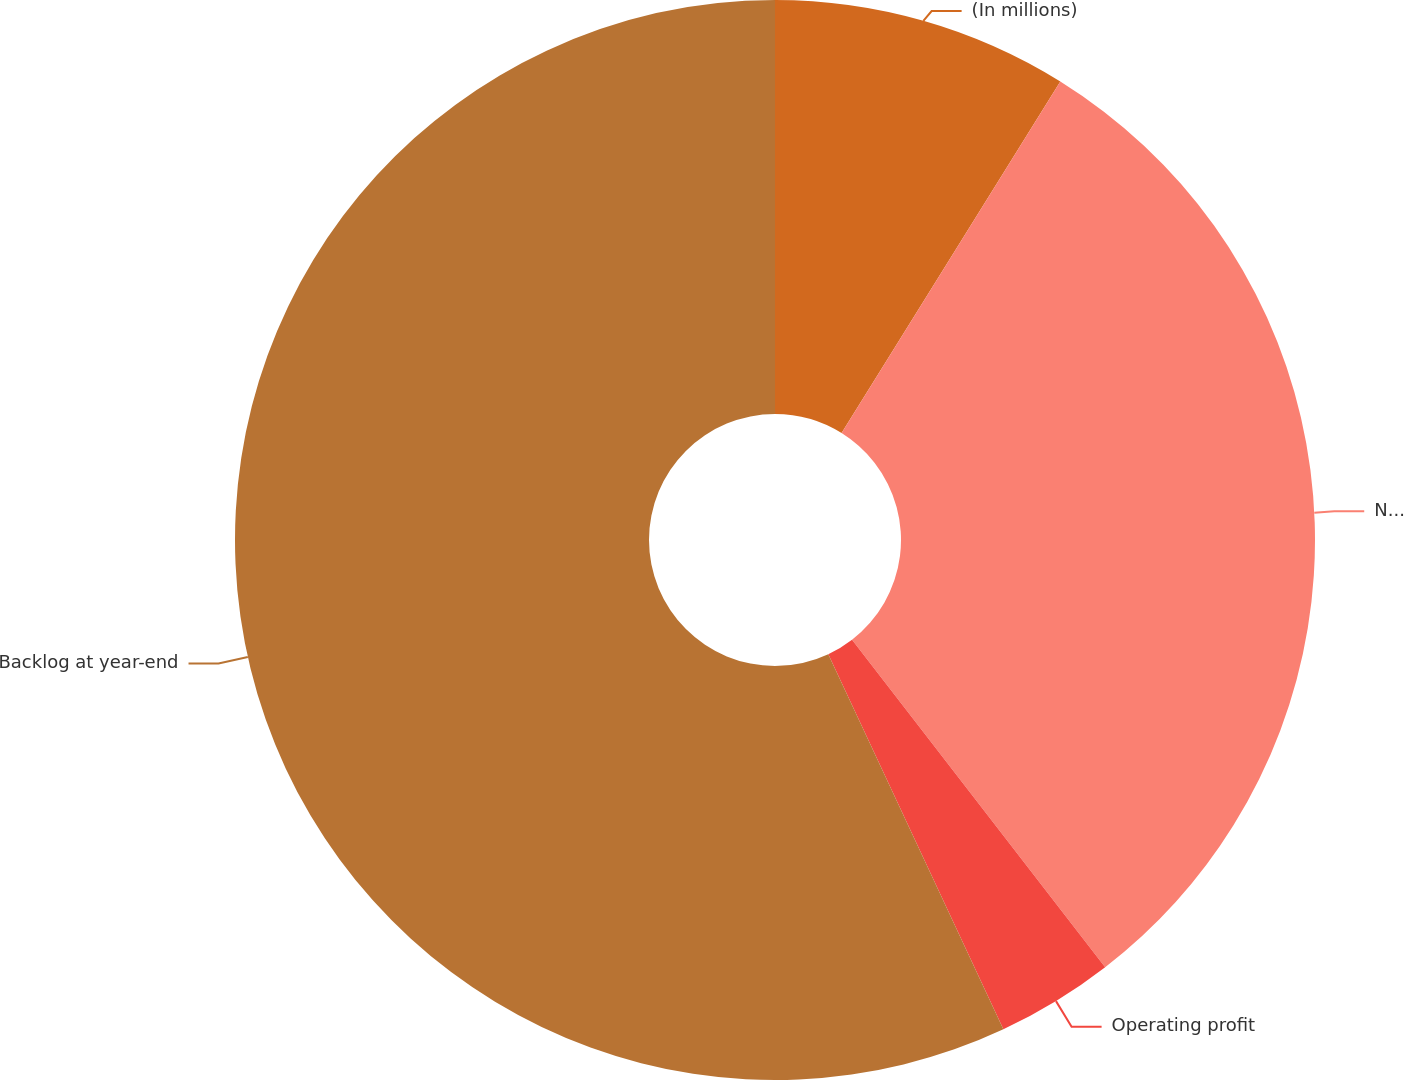Convert chart. <chart><loc_0><loc_0><loc_500><loc_500><pie_chart><fcel>(In millions)<fcel>Net sales<fcel>Operating profit<fcel>Backlog at year-end<nl><fcel>8.86%<fcel>30.67%<fcel>3.52%<fcel>56.95%<nl></chart> 